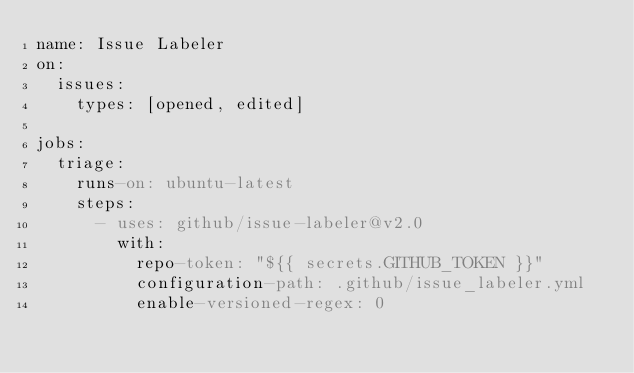Convert code to text. <code><loc_0><loc_0><loc_500><loc_500><_YAML_>name: Issue Labeler
on:
  issues:
    types: [opened, edited]

jobs:
  triage:
    runs-on: ubuntu-latest
    steps:
      - uses: github/issue-labeler@v2.0
        with:
          repo-token: "${{ secrets.GITHUB_TOKEN }}"
          configuration-path: .github/issue_labeler.yml
          enable-versioned-regex: 0
</code> 